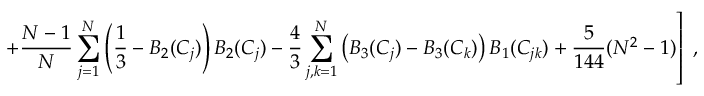<formula> <loc_0><loc_0><loc_500><loc_500>+ { \frac { N - 1 } { N } } \sum _ { j = 1 } ^ { N } \left ( \frac { 1 } { 3 } - B _ { 2 } ( C _ { j } ) \right ) B _ { 2 } ( C _ { j } ) - { \frac { 4 } { 3 } } \sum _ { j , k = 1 } ^ { N } \left ( B _ { 3 } ( C _ { j } ) - B _ { 3 } ( C _ { k } ) \right ) B _ { 1 } ( C _ { j k } ) + { \frac { 5 } { 1 4 4 } } ( N ^ { 2 } - 1 ) \right ] \, ,</formula> 